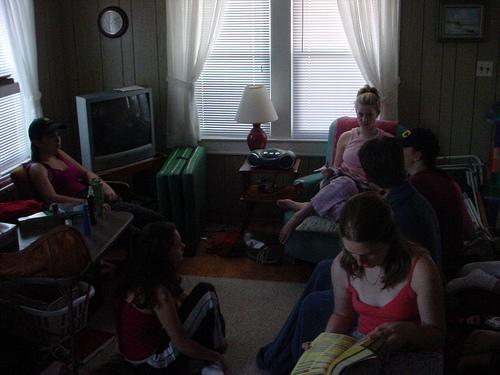What kind of pants is the girl in pink wearing? pajama 